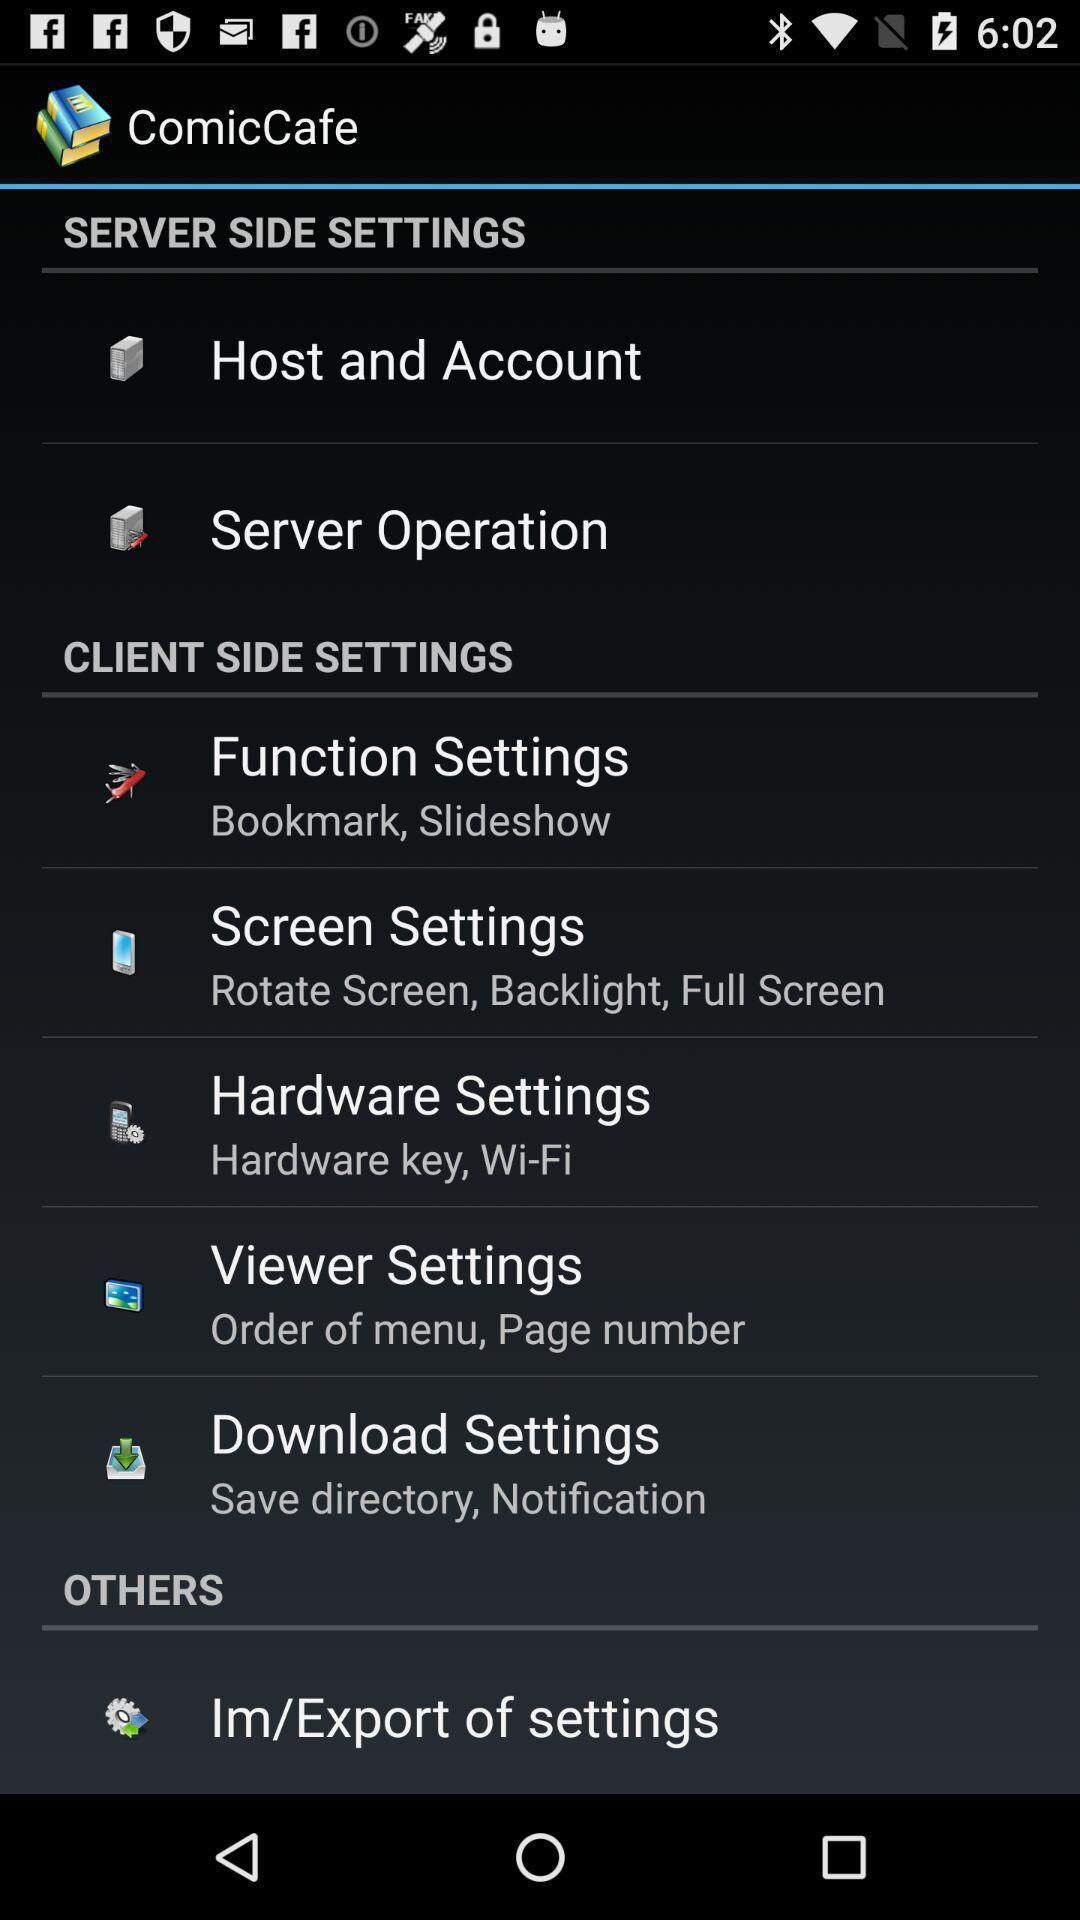Please provide a description for this image. Page showing different setting options on an app. 